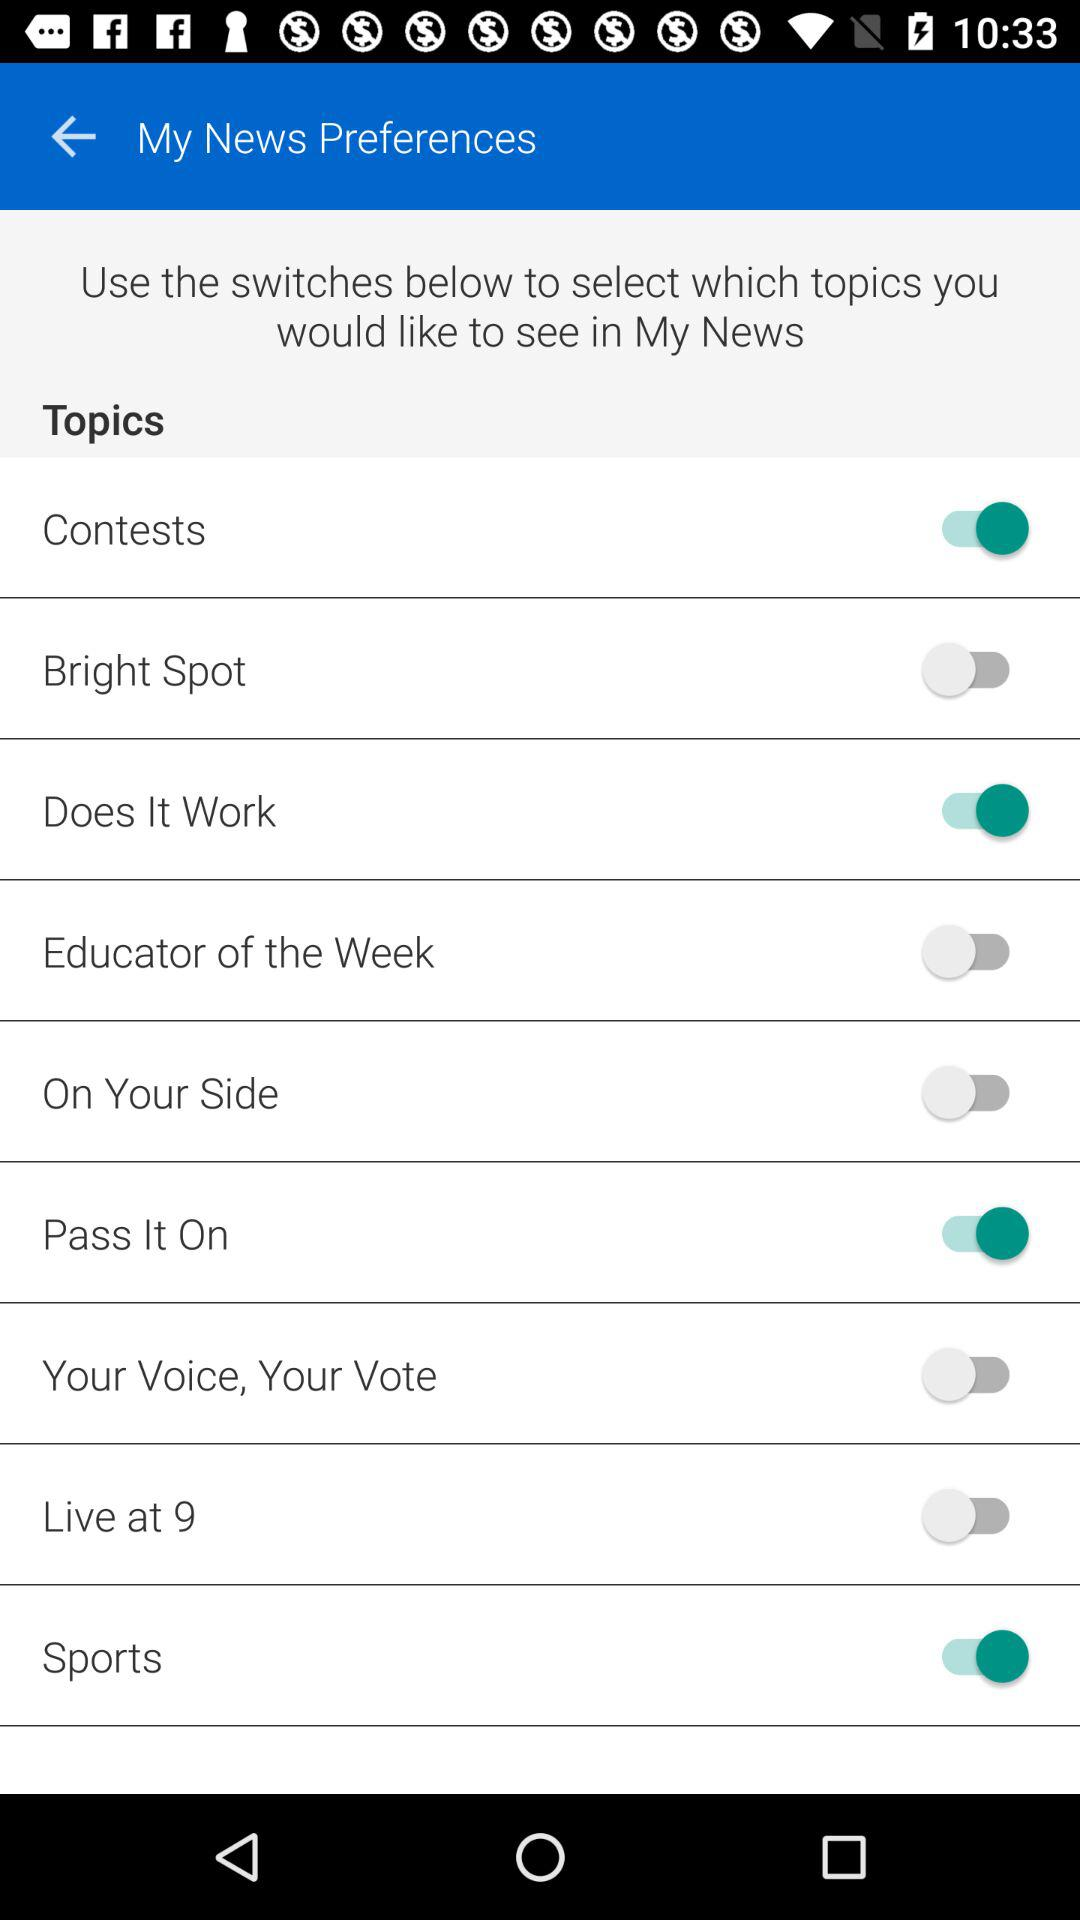How many topics are there in total?
Answer the question using a single word or phrase. 9 